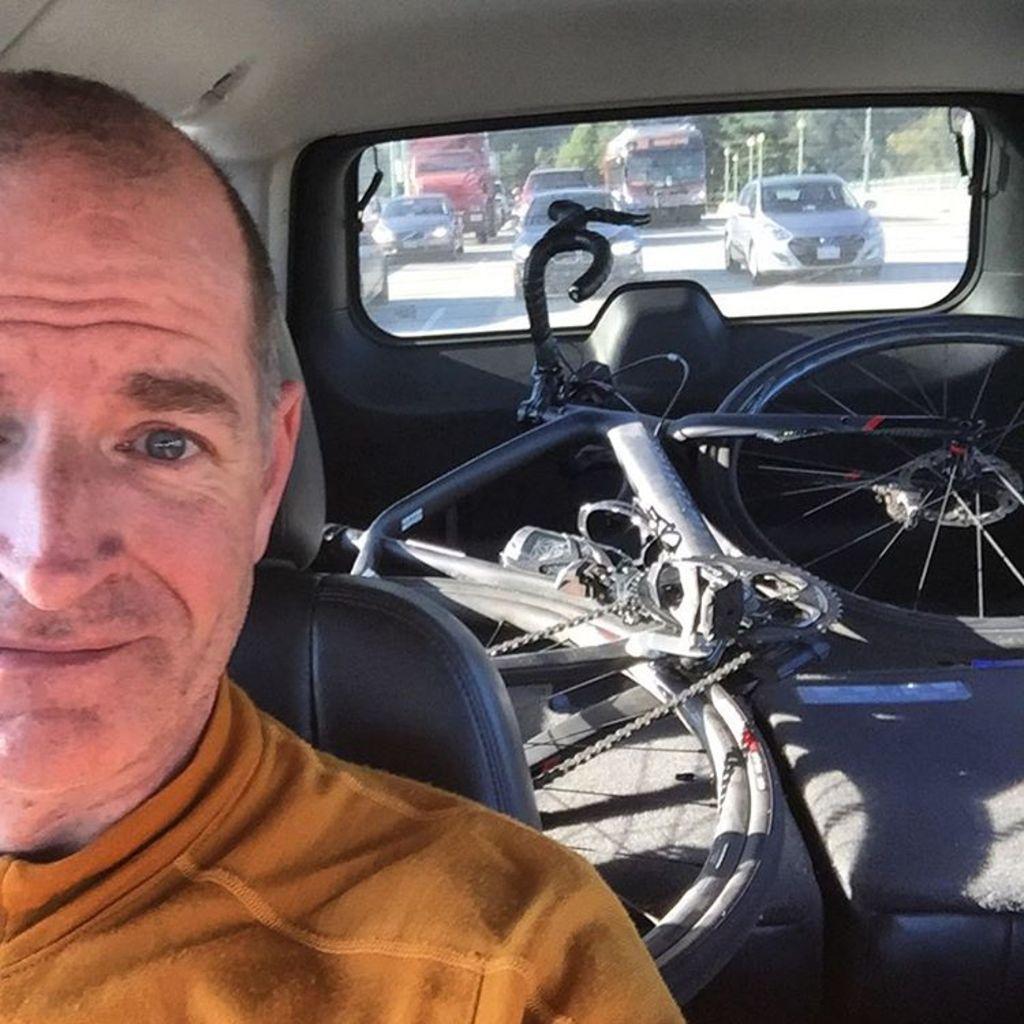How would you summarize this image in a sentence or two? In this image we can see there is a person sitting in the car and there is a bicycle. And through the car window we can see there are vehicles on the road and there are light poles and trees. 